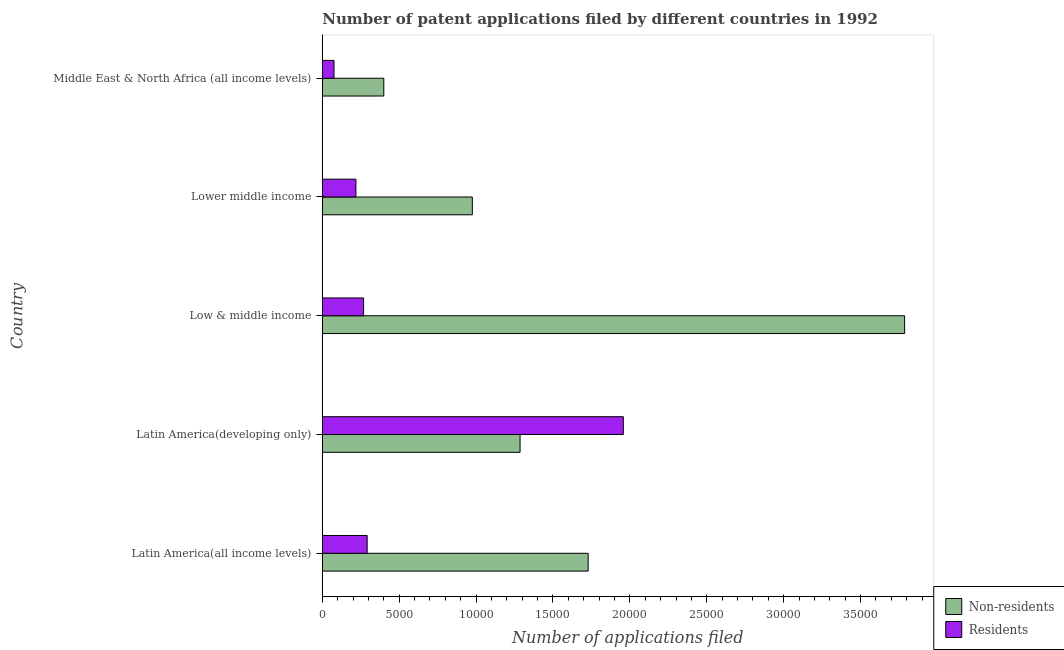How many different coloured bars are there?
Provide a succinct answer. 2. How many groups of bars are there?
Your answer should be very brief. 5. Are the number of bars per tick equal to the number of legend labels?
Your answer should be very brief. Yes. Are the number of bars on each tick of the Y-axis equal?
Provide a short and direct response. Yes. How many bars are there on the 5th tick from the bottom?
Give a very brief answer. 2. What is the label of the 1st group of bars from the top?
Your answer should be compact. Middle East & North Africa (all income levels). What is the number of patent applications by non residents in Latin America(all income levels)?
Make the answer very short. 1.73e+04. Across all countries, what is the maximum number of patent applications by non residents?
Offer a very short reply. 3.79e+04. Across all countries, what is the minimum number of patent applications by non residents?
Your response must be concise. 3997. In which country was the number of patent applications by non residents maximum?
Provide a short and direct response. Low & middle income. In which country was the number of patent applications by residents minimum?
Your answer should be compact. Middle East & North Africa (all income levels). What is the total number of patent applications by residents in the graph?
Provide a succinct answer. 2.81e+04. What is the difference between the number of patent applications by non residents in Latin America(all income levels) and that in Latin America(developing only)?
Offer a very short reply. 4429. What is the difference between the number of patent applications by residents in Latin America(developing only) and the number of patent applications by non residents in Middle East & North Africa (all income levels)?
Offer a terse response. 1.56e+04. What is the average number of patent applications by non residents per country?
Your answer should be compact. 1.64e+04. What is the difference between the number of patent applications by residents and number of patent applications by non residents in Latin America(developing only)?
Your answer should be very brief. 6715. What is the ratio of the number of patent applications by residents in Latin America(all income levels) to that in Latin America(developing only)?
Give a very brief answer. 0.15. Is the number of patent applications by non residents in Lower middle income less than that in Middle East & North Africa (all income levels)?
Offer a very short reply. No. What is the difference between the highest and the second highest number of patent applications by residents?
Offer a very short reply. 1.67e+04. What is the difference between the highest and the lowest number of patent applications by non residents?
Your answer should be very brief. 3.39e+04. In how many countries, is the number of patent applications by non residents greater than the average number of patent applications by non residents taken over all countries?
Offer a very short reply. 2. What does the 1st bar from the top in Low & middle income represents?
Offer a terse response. Residents. What does the 2nd bar from the bottom in Low & middle income represents?
Provide a short and direct response. Residents. How many bars are there?
Give a very brief answer. 10. Are the values on the major ticks of X-axis written in scientific E-notation?
Your response must be concise. No. Does the graph contain any zero values?
Your answer should be compact. No. Where does the legend appear in the graph?
Provide a succinct answer. Bottom right. How are the legend labels stacked?
Provide a succinct answer. Vertical. What is the title of the graph?
Your answer should be very brief. Number of patent applications filed by different countries in 1992. Does "International Tourists" appear as one of the legend labels in the graph?
Provide a succinct answer. No. What is the label or title of the X-axis?
Keep it short and to the point. Number of applications filed. What is the Number of applications filed of Non-residents in Latin America(all income levels)?
Your answer should be compact. 1.73e+04. What is the Number of applications filed in Residents in Latin America(all income levels)?
Give a very brief answer. 2915. What is the Number of applications filed in Non-residents in Latin America(developing only)?
Keep it short and to the point. 1.29e+04. What is the Number of applications filed of Residents in Latin America(developing only)?
Ensure brevity in your answer.  1.96e+04. What is the Number of applications filed in Non-residents in Low & middle income?
Your answer should be very brief. 3.79e+04. What is the Number of applications filed of Residents in Low & middle income?
Make the answer very short. 2683. What is the Number of applications filed in Non-residents in Lower middle income?
Give a very brief answer. 9755. What is the Number of applications filed in Residents in Lower middle income?
Your answer should be compact. 2184. What is the Number of applications filed of Non-residents in Middle East & North Africa (all income levels)?
Ensure brevity in your answer.  3997. What is the Number of applications filed in Residents in Middle East & North Africa (all income levels)?
Your answer should be compact. 760. Across all countries, what is the maximum Number of applications filed of Non-residents?
Offer a terse response. 3.79e+04. Across all countries, what is the maximum Number of applications filed of Residents?
Your response must be concise. 1.96e+04. Across all countries, what is the minimum Number of applications filed in Non-residents?
Offer a very short reply. 3997. Across all countries, what is the minimum Number of applications filed in Residents?
Ensure brevity in your answer.  760. What is the total Number of applications filed of Non-residents in the graph?
Keep it short and to the point. 8.18e+04. What is the total Number of applications filed in Residents in the graph?
Provide a short and direct response. 2.81e+04. What is the difference between the Number of applications filed of Non-residents in Latin America(all income levels) and that in Latin America(developing only)?
Provide a short and direct response. 4429. What is the difference between the Number of applications filed in Residents in Latin America(all income levels) and that in Latin America(developing only)?
Provide a short and direct response. -1.67e+04. What is the difference between the Number of applications filed in Non-residents in Latin America(all income levels) and that in Low & middle income?
Your response must be concise. -2.06e+04. What is the difference between the Number of applications filed in Residents in Latin America(all income levels) and that in Low & middle income?
Keep it short and to the point. 232. What is the difference between the Number of applications filed in Non-residents in Latin America(all income levels) and that in Lower middle income?
Keep it short and to the point. 7533. What is the difference between the Number of applications filed of Residents in Latin America(all income levels) and that in Lower middle income?
Give a very brief answer. 731. What is the difference between the Number of applications filed of Non-residents in Latin America(all income levels) and that in Middle East & North Africa (all income levels)?
Your answer should be compact. 1.33e+04. What is the difference between the Number of applications filed in Residents in Latin America(all income levels) and that in Middle East & North Africa (all income levels)?
Ensure brevity in your answer.  2155. What is the difference between the Number of applications filed of Non-residents in Latin America(developing only) and that in Low & middle income?
Provide a succinct answer. -2.50e+04. What is the difference between the Number of applications filed in Residents in Latin America(developing only) and that in Low & middle income?
Your answer should be very brief. 1.69e+04. What is the difference between the Number of applications filed of Non-residents in Latin America(developing only) and that in Lower middle income?
Offer a very short reply. 3104. What is the difference between the Number of applications filed of Residents in Latin America(developing only) and that in Lower middle income?
Your answer should be compact. 1.74e+04. What is the difference between the Number of applications filed of Non-residents in Latin America(developing only) and that in Middle East & North Africa (all income levels)?
Your response must be concise. 8862. What is the difference between the Number of applications filed in Residents in Latin America(developing only) and that in Middle East & North Africa (all income levels)?
Offer a very short reply. 1.88e+04. What is the difference between the Number of applications filed of Non-residents in Low & middle income and that in Lower middle income?
Make the answer very short. 2.81e+04. What is the difference between the Number of applications filed of Residents in Low & middle income and that in Lower middle income?
Give a very brief answer. 499. What is the difference between the Number of applications filed of Non-residents in Low & middle income and that in Middle East & North Africa (all income levels)?
Provide a short and direct response. 3.39e+04. What is the difference between the Number of applications filed in Residents in Low & middle income and that in Middle East & North Africa (all income levels)?
Provide a short and direct response. 1923. What is the difference between the Number of applications filed in Non-residents in Lower middle income and that in Middle East & North Africa (all income levels)?
Your answer should be compact. 5758. What is the difference between the Number of applications filed of Residents in Lower middle income and that in Middle East & North Africa (all income levels)?
Keep it short and to the point. 1424. What is the difference between the Number of applications filed of Non-residents in Latin America(all income levels) and the Number of applications filed of Residents in Latin America(developing only)?
Provide a succinct answer. -2286. What is the difference between the Number of applications filed of Non-residents in Latin America(all income levels) and the Number of applications filed of Residents in Low & middle income?
Your response must be concise. 1.46e+04. What is the difference between the Number of applications filed in Non-residents in Latin America(all income levels) and the Number of applications filed in Residents in Lower middle income?
Offer a very short reply. 1.51e+04. What is the difference between the Number of applications filed of Non-residents in Latin America(all income levels) and the Number of applications filed of Residents in Middle East & North Africa (all income levels)?
Make the answer very short. 1.65e+04. What is the difference between the Number of applications filed of Non-residents in Latin America(developing only) and the Number of applications filed of Residents in Low & middle income?
Ensure brevity in your answer.  1.02e+04. What is the difference between the Number of applications filed in Non-residents in Latin America(developing only) and the Number of applications filed in Residents in Lower middle income?
Provide a short and direct response. 1.07e+04. What is the difference between the Number of applications filed in Non-residents in Latin America(developing only) and the Number of applications filed in Residents in Middle East & North Africa (all income levels)?
Your answer should be compact. 1.21e+04. What is the difference between the Number of applications filed of Non-residents in Low & middle income and the Number of applications filed of Residents in Lower middle income?
Provide a succinct answer. 3.57e+04. What is the difference between the Number of applications filed of Non-residents in Low & middle income and the Number of applications filed of Residents in Middle East & North Africa (all income levels)?
Provide a succinct answer. 3.71e+04. What is the difference between the Number of applications filed in Non-residents in Lower middle income and the Number of applications filed in Residents in Middle East & North Africa (all income levels)?
Keep it short and to the point. 8995. What is the average Number of applications filed in Non-residents per country?
Ensure brevity in your answer.  1.64e+04. What is the average Number of applications filed of Residents per country?
Your answer should be compact. 5623.2. What is the difference between the Number of applications filed in Non-residents and Number of applications filed in Residents in Latin America(all income levels)?
Offer a very short reply. 1.44e+04. What is the difference between the Number of applications filed in Non-residents and Number of applications filed in Residents in Latin America(developing only)?
Your answer should be very brief. -6715. What is the difference between the Number of applications filed of Non-residents and Number of applications filed of Residents in Low & middle income?
Your answer should be compact. 3.52e+04. What is the difference between the Number of applications filed of Non-residents and Number of applications filed of Residents in Lower middle income?
Ensure brevity in your answer.  7571. What is the difference between the Number of applications filed of Non-residents and Number of applications filed of Residents in Middle East & North Africa (all income levels)?
Keep it short and to the point. 3237. What is the ratio of the Number of applications filed of Non-residents in Latin America(all income levels) to that in Latin America(developing only)?
Provide a succinct answer. 1.34. What is the ratio of the Number of applications filed in Residents in Latin America(all income levels) to that in Latin America(developing only)?
Provide a short and direct response. 0.15. What is the ratio of the Number of applications filed in Non-residents in Latin America(all income levels) to that in Low & middle income?
Keep it short and to the point. 0.46. What is the ratio of the Number of applications filed of Residents in Latin America(all income levels) to that in Low & middle income?
Your answer should be compact. 1.09. What is the ratio of the Number of applications filed of Non-residents in Latin America(all income levels) to that in Lower middle income?
Make the answer very short. 1.77. What is the ratio of the Number of applications filed in Residents in Latin America(all income levels) to that in Lower middle income?
Keep it short and to the point. 1.33. What is the ratio of the Number of applications filed in Non-residents in Latin America(all income levels) to that in Middle East & North Africa (all income levels)?
Offer a very short reply. 4.33. What is the ratio of the Number of applications filed in Residents in Latin America(all income levels) to that in Middle East & North Africa (all income levels)?
Provide a short and direct response. 3.84. What is the ratio of the Number of applications filed in Non-residents in Latin America(developing only) to that in Low & middle income?
Your answer should be very brief. 0.34. What is the ratio of the Number of applications filed of Residents in Latin America(developing only) to that in Low & middle income?
Provide a short and direct response. 7.3. What is the ratio of the Number of applications filed of Non-residents in Latin America(developing only) to that in Lower middle income?
Give a very brief answer. 1.32. What is the ratio of the Number of applications filed of Residents in Latin America(developing only) to that in Lower middle income?
Keep it short and to the point. 8.96. What is the ratio of the Number of applications filed of Non-residents in Latin America(developing only) to that in Middle East & North Africa (all income levels)?
Your answer should be very brief. 3.22. What is the ratio of the Number of applications filed in Residents in Latin America(developing only) to that in Middle East & North Africa (all income levels)?
Ensure brevity in your answer.  25.76. What is the ratio of the Number of applications filed of Non-residents in Low & middle income to that in Lower middle income?
Your response must be concise. 3.88. What is the ratio of the Number of applications filed in Residents in Low & middle income to that in Lower middle income?
Keep it short and to the point. 1.23. What is the ratio of the Number of applications filed in Non-residents in Low & middle income to that in Middle East & North Africa (all income levels)?
Keep it short and to the point. 9.47. What is the ratio of the Number of applications filed in Residents in Low & middle income to that in Middle East & North Africa (all income levels)?
Your answer should be very brief. 3.53. What is the ratio of the Number of applications filed of Non-residents in Lower middle income to that in Middle East & North Africa (all income levels)?
Your answer should be compact. 2.44. What is the ratio of the Number of applications filed of Residents in Lower middle income to that in Middle East & North Africa (all income levels)?
Make the answer very short. 2.87. What is the difference between the highest and the second highest Number of applications filed of Non-residents?
Your response must be concise. 2.06e+04. What is the difference between the highest and the second highest Number of applications filed of Residents?
Keep it short and to the point. 1.67e+04. What is the difference between the highest and the lowest Number of applications filed of Non-residents?
Provide a short and direct response. 3.39e+04. What is the difference between the highest and the lowest Number of applications filed of Residents?
Make the answer very short. 1.88e+04. 